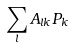<formula> <loc_0><loc_0><loc_500><loc_500>\sum _ { l } A _ { l k } P _ { k }</formula> 